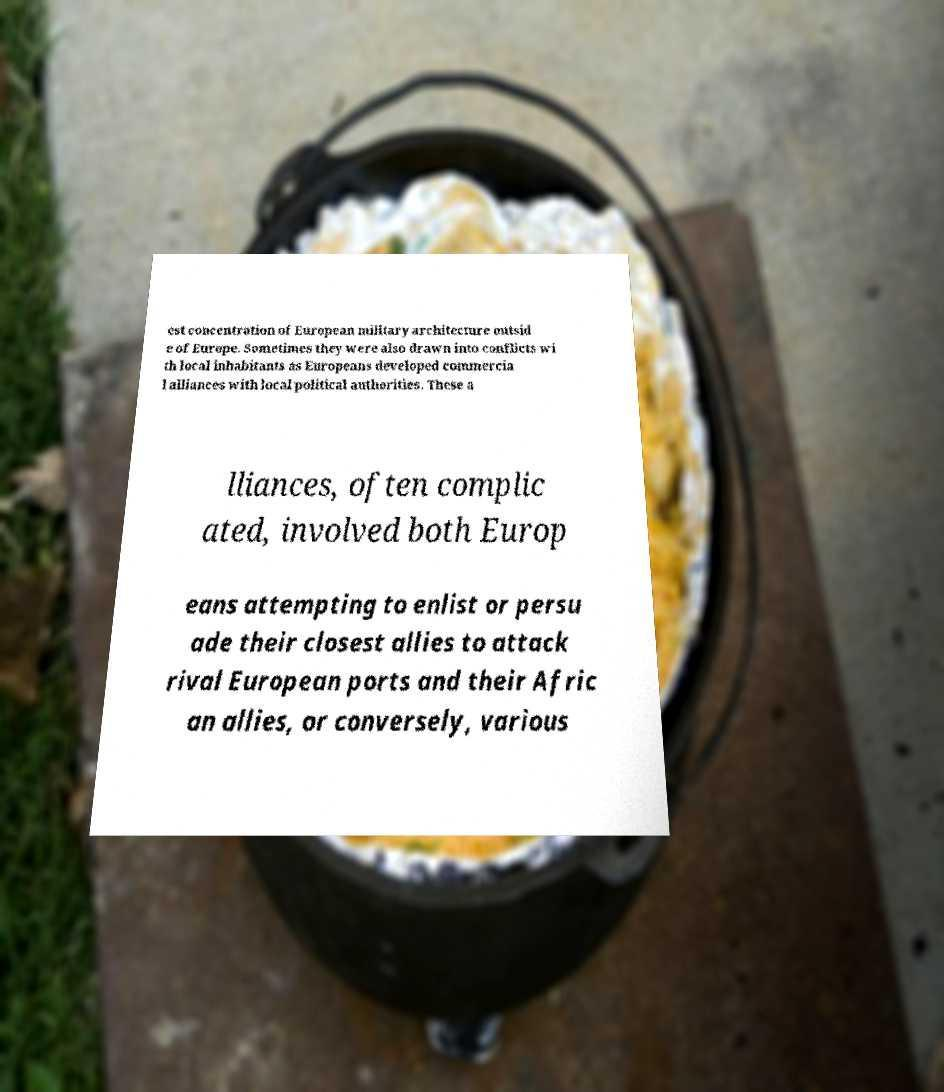Could you assist in decoding the text presented in this image and type it out clearly? est concentration of European military architecture outsid e of Europe. Sometimes they were also drawn into conflicts wi th local inhabitants as Europeans developed commercia l alliances with local political authorities. These a lliances, often complic ated, involved both Europ eans attempting to enlist or persu ade their closest allies to attack rival European ports and their Afric an allies, or conversely, various 